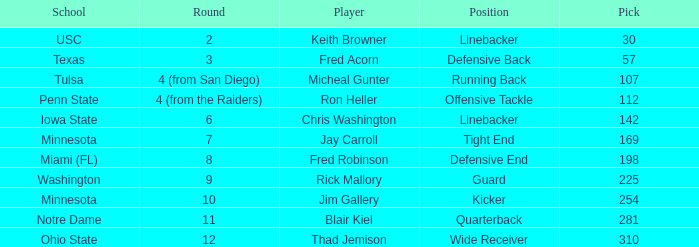Which Round is pick 112 in? 4 (from the Raiders). 